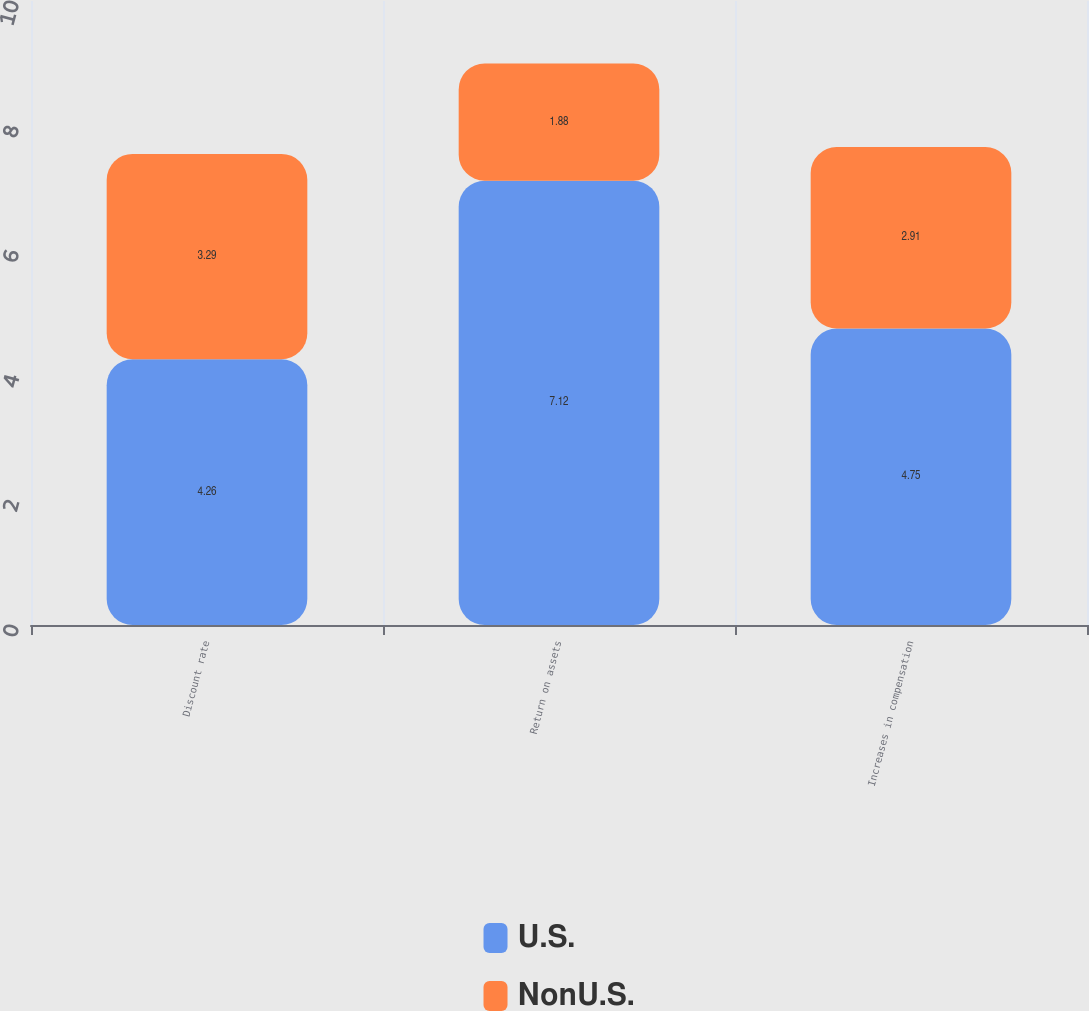Convert chart. <chart><loc_0><loc_0><loc_500><loc_500><stacked_bar_chart><ecel><fcel>Discount rate<fcel>Return on assets<fcel>Increases in compensation<nl><fcel>U.S.<fcel>4.26<fcel>7.12<fcel>4.75<nl><fcel>NonU.S.<fcel>3.29<fcel>1.88<fcel>2.91<nl></chart> 